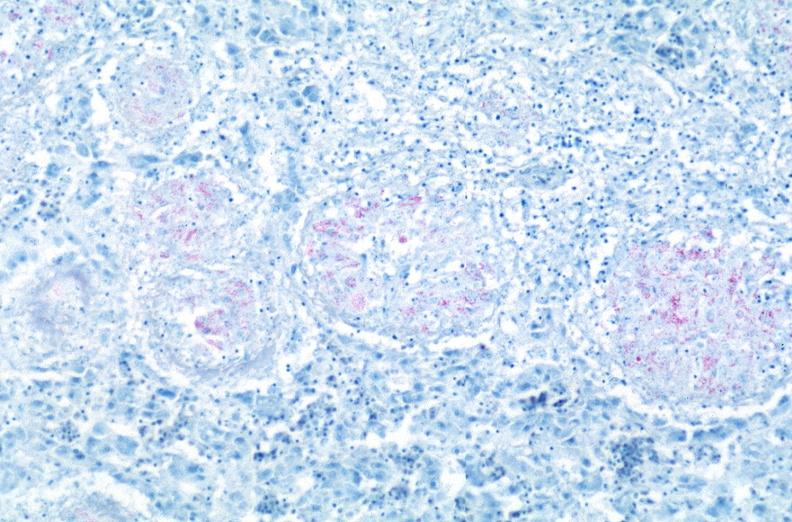what does this image show?
Answer the question using a single word or phrase. Lung 